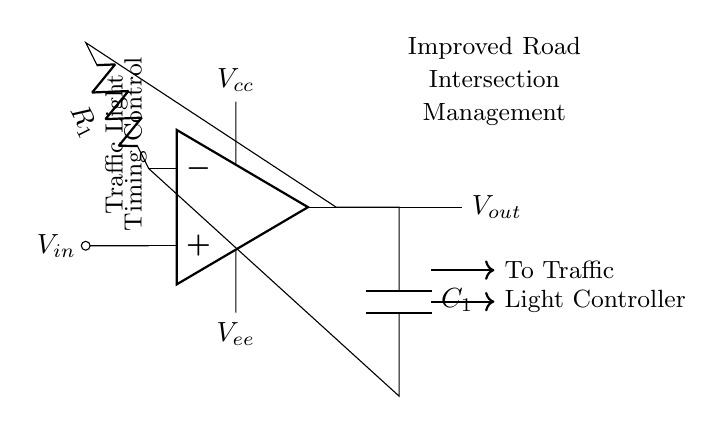What is the type of this circuit? The circuit is an oscillator, as indicated by the presence of an operational amplifier configured to create an oscillation for timing control.
Answer: oscillator What is the input voltage source labeled as? The input voltage source in the circuit is labeled as "Vin" which is evident in the connection path to the operational amplifier.
Answer: Vin What component provides timing control? The timing control is being provided by the capacitor, labeled "C1," which is connected in a feedback loop that sets the oscillation frequency.
Answer: C1 What is the supply voltage for the op-amp? The supply voltage for the op-amp is labeled as "Vcc," located at the top connection of the operational amplifier.
Answer: Vcc How many resistors are present in the circuit? There is one resistor present in the circuit, labeled as "R1," which is in series with the input to the operational amplifier.
Answer: 1 What is the output of the circuit directed towards? The output of the circuit, labeled "Vout," is directed towards two components: the traffic light and the light controller, indicating its practical application.
Answer: Traffic Light and Light Controller Which part of the circuit ensures stability in oscillation? The feedback loop including the capacitor "C1" and resistor "R1" is essential for stability in oscillation, as these components together control the charge and discharge cycles of the oscillator.
Answer: C1 and R1 